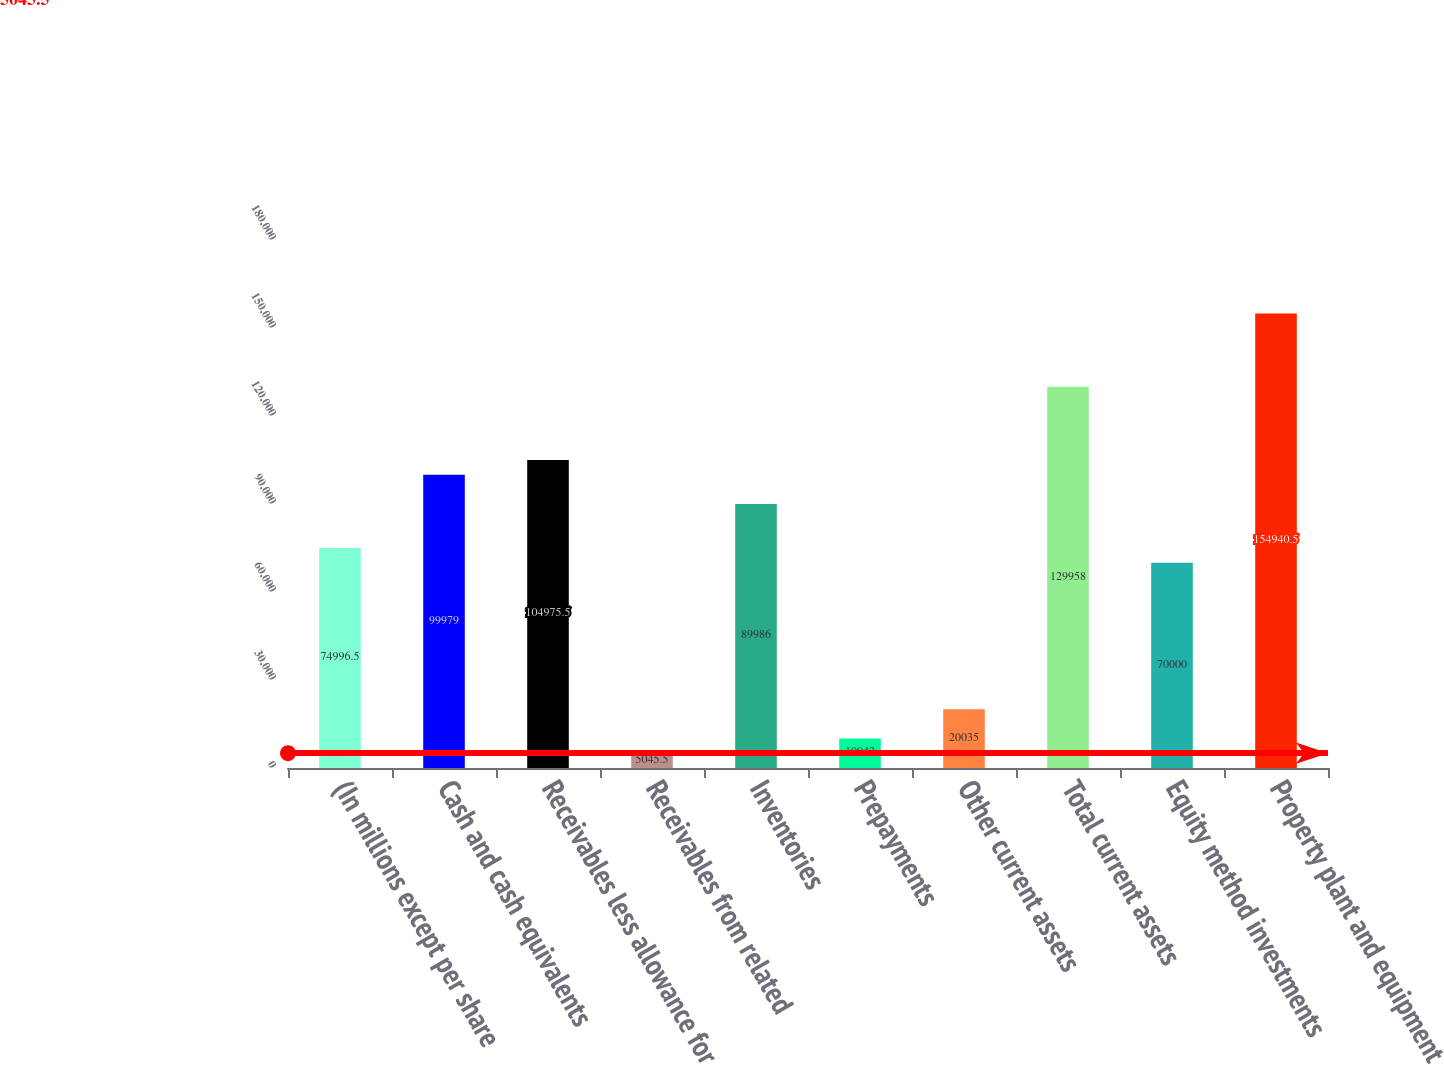Convert chart to OTSL. <chart><loc_0><loc_0><loc_500><loc_500><bar_chart><fcel>(In millions except per share<fcel>Cash and cash equivalents<fcel>Receivables less allowance for<fcel>Receivables from related<fcel>Inventories<fcel>Prepayments<fcel>Other current assets<fcel>Total current assets<fcel>Equity method investments<fcel>Property plant and equipment<nl><fcel>74996.5<fcel>99979<fcel>104976<fcel>5045.5<fcel>89986<fcel>10042<fcel>20035<fcel>129958<fcel>70000<fcel>154940<nl></chart> 